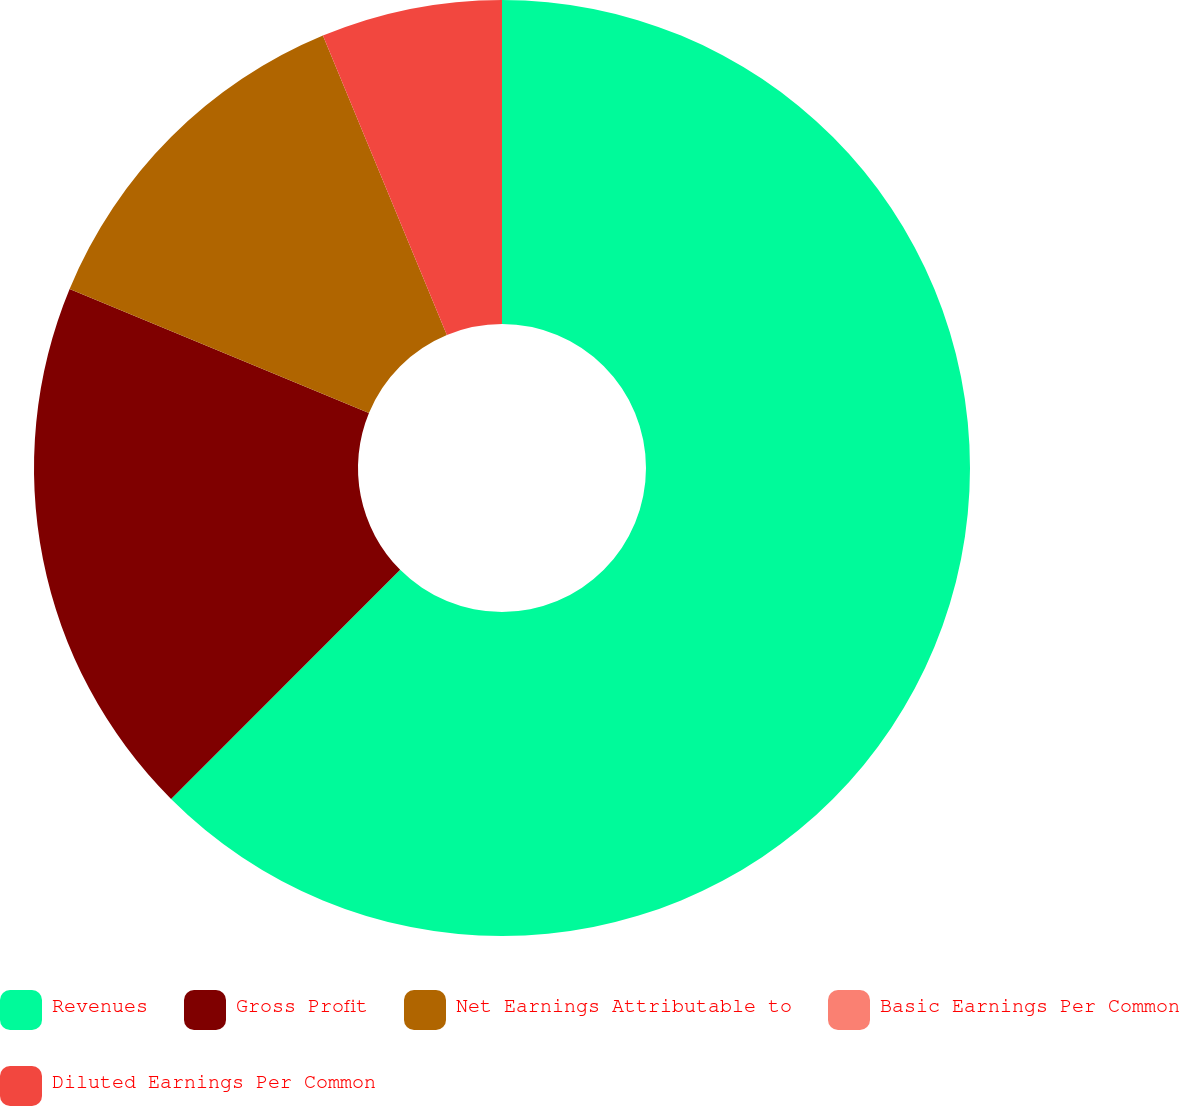<chart> <loc_0><loc_0><loc_500><loc_500><pie_chart><fcel>Revenues<fcel>Gross Profit<fcel>Net Earnings Attributable to<fcel>Basic Earnings Per Common<fcel>Diluted Earnings Per Common<nl><fcel>62.5%<fcel>18.75%<fcel>12.5%<fcel>0.0%<fcel>6.25%<nl></chart> 